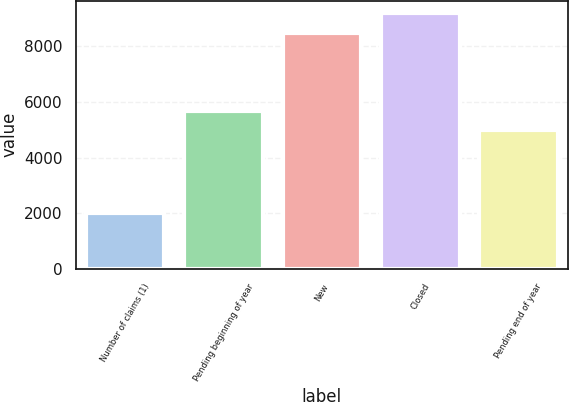Convert chart to OTSL. <chart><loc_0><loc_0><loc_500><loc_500><bar_chart><fcel>Number of claims (1)<fcel>Pending beginning of year<fcel>New<fcel>Closed<fcel>Pending end of year<nl><fcel>2017<fcel>5671.2<fcel>8494<fcel>9182.2<fcel>4983<nl></chart> 